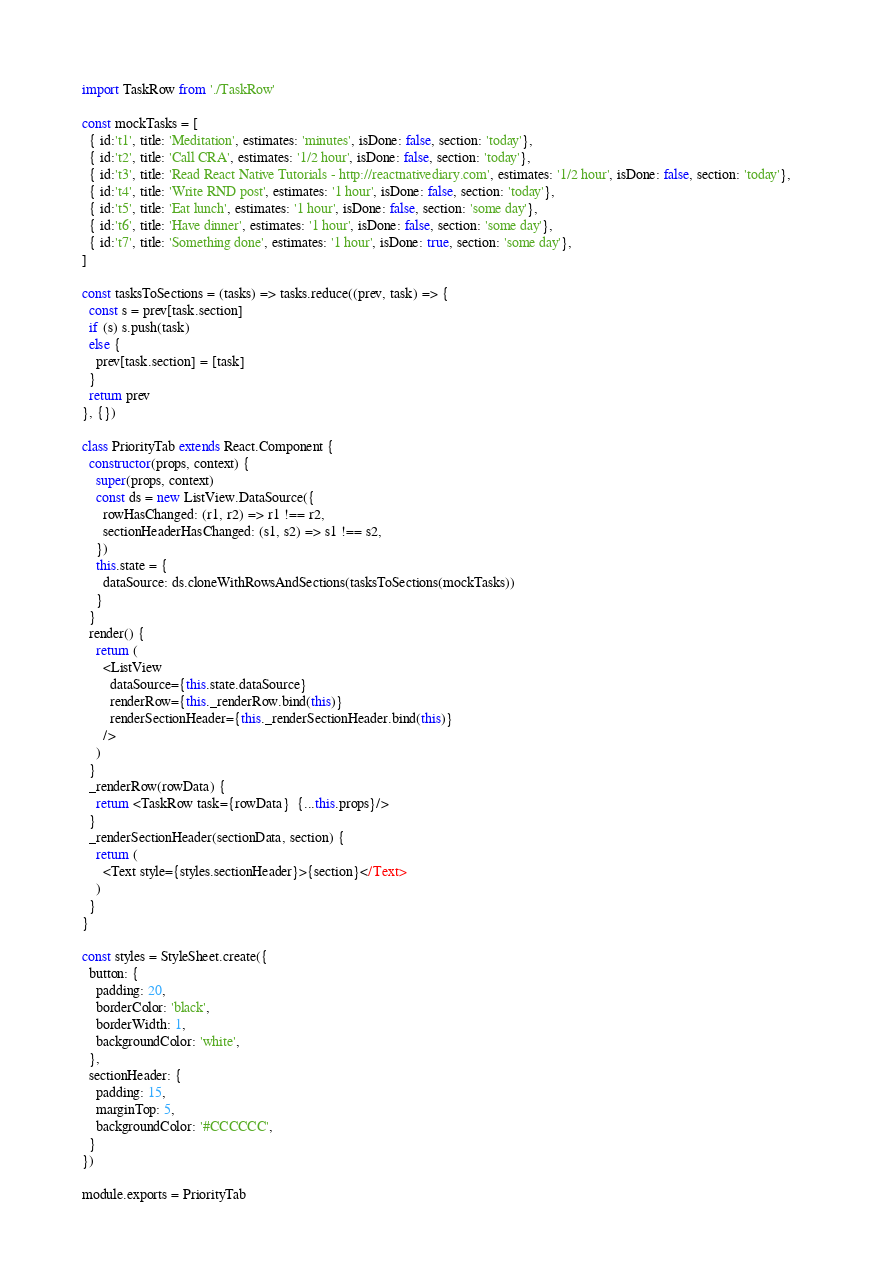<code> <loc_0><loc_0><loc_500><loc_500><_JavaScript_>import TaskRow from './TaskRow'

const mockTasks = [
  { id:'t1', title: 'Meditation', estimates: 'minutes', isDone: false, section: 'today'},
  { id:'t2', title: 'Call CRA', estimates: '1/2 hour', isDone: false, section: 'today'},
  { id:'t3', title: 'Read React Native Tutorials - http://reactnativediary.com', estimates: '1/2 hour', isDone: false, section: 'today'},
  { id:'t4', title: 'Write RND post', estimates: '1 hour', isDone: false, section: 'today'},
  { id:'t5', title: 'Eat lunch', estimates: '1 hour', isDone: false, section: 'some day'},
  { id:'t6', title: 'Have dinner', estimates: '1 hour', isDone: false, section: 'some day'},
  { id:'t7', title: 'Something done', estimates: '1 hour', isDone: true, section: 'some day'},
]

const tasksToSections = (tasks) => tasks.reduce((prev, task) => {
  const s = prev[task.section]
  if (s) s.push(task)
  else {
    prev[task.section] = [task]
  }
  return prev
}, {})

class PriorityTab extends React.Component {
  constructor(props, context) {
    super(props, context)
    const ds = new ListView.DataSource({
      rowHasChanged: (r1, r2) => r1 !== r2,
      sectionHeaderHasChanged: (s1, s2) => s1 !== s2,
    })
    this.state = {
      dataSource: ds.cloneWithRowsAndSections(tasksToSections(mockTasks))
    }
  }
  render() {
    return (
      <ListView
        dataSource={this.state.dataSource}
        renderRow={this._renderRow.bind(this)}
        renderSectionHeader={this._renderSectionHeader.bind(this)}
      />
    )
  }
  _renderRow(rowData) {
    return <TaskRow task={rowData}  {...this.props}/>
  }
  _renderSectionHeader(sectionData, section) {
    return (
      <Text style={styles.sectionHeader}>{section}</Text>
    )
  }
}

const styles = StyleSheet.create({
  button: {
    padding: 20,
    borderColor: 'black',
    borderWidth: 1,
    backgroundColor: 'white',
  },
  sectionHeader: {
    padding: 15,
    marginTop: 5,
    backgroundColor: '#CCCCCC',
  }
})

module.exports = PriorityTab
</code> 